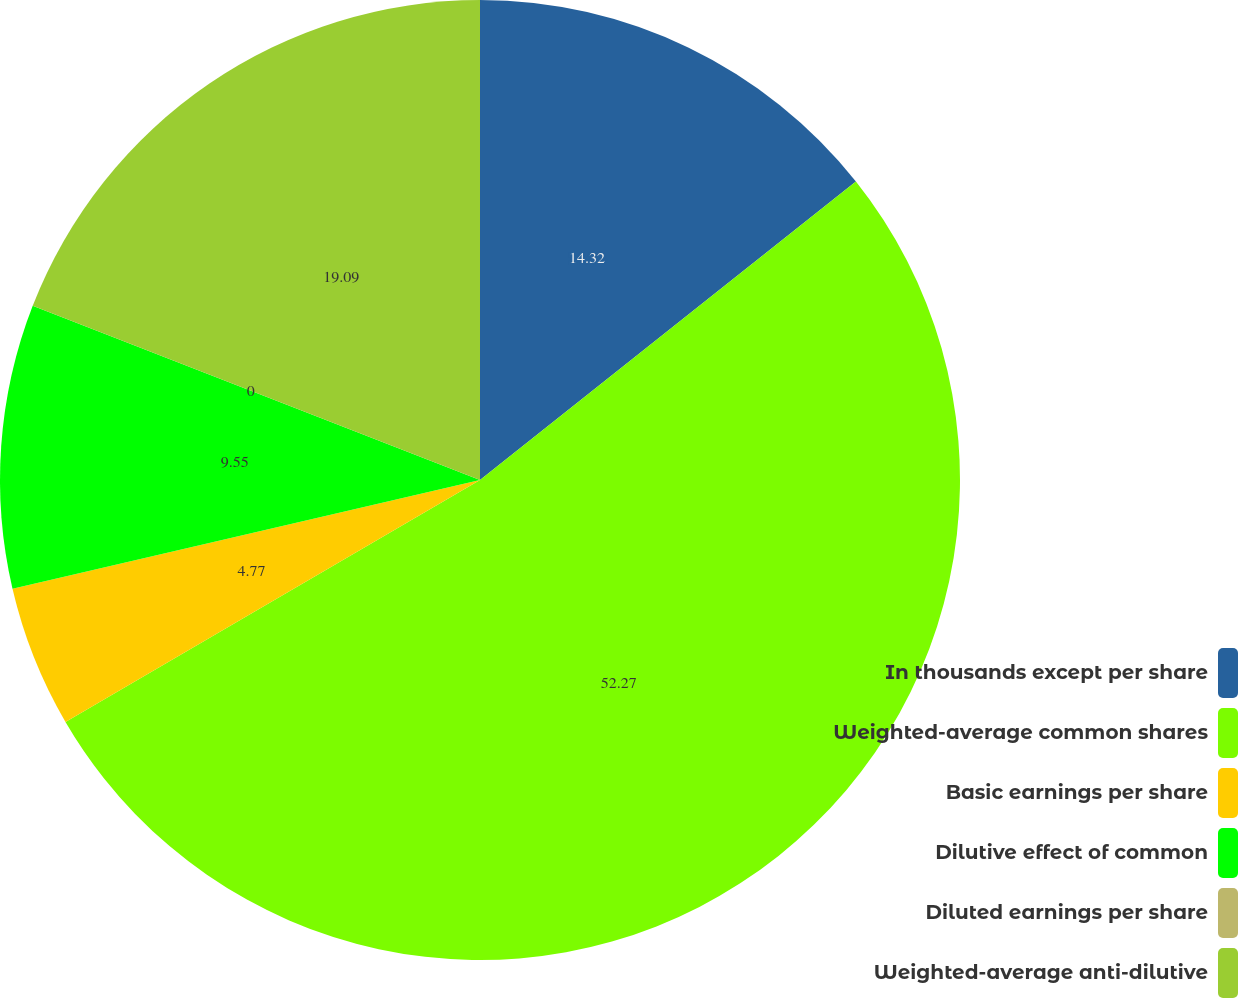<chart> <loc_0><loc_0><loc_500><loc_500><pie_chart><fcel>In thousands except per share<fcel>Weighted-average common shares<fcel>Basic earnings per share<fcel>Dilutive effect of common<fcel>Diluted earnings per share<fcel>Weighted-average anti-dilutive<nl><fcel>14.32%<fcel>52.27%<fcel>4.77%<fcel>9.55%<fcel>0.0%<fcel>19.09%<nl></chart> 